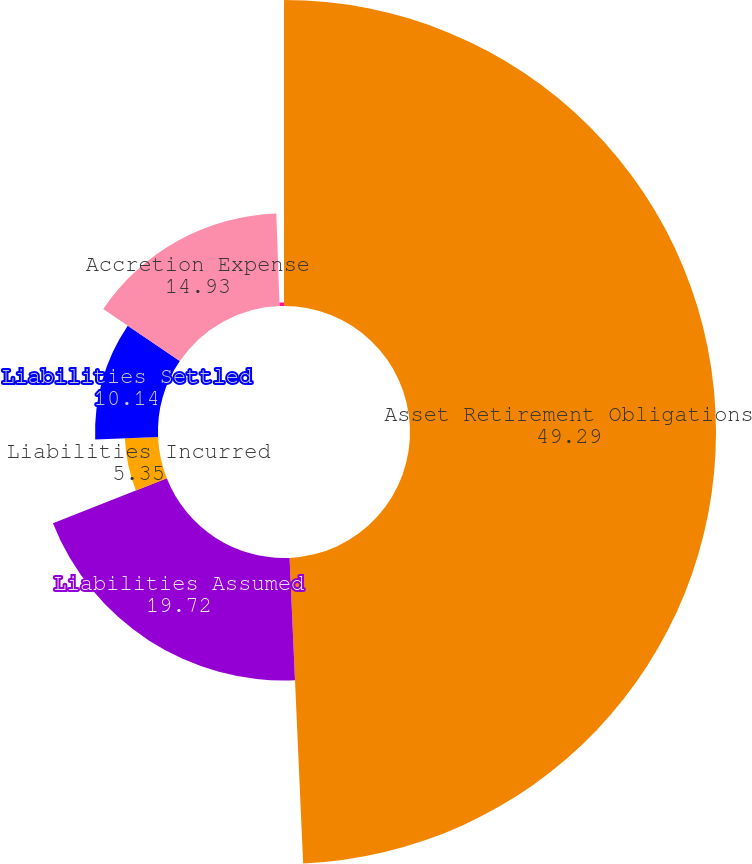Convert chart. <chart><loc_0><loc_0><loc_500><loc_500><pie_chart><fcel>Asset Retirement Obligations<fcel>Liabilities Assumed<fcel>Liabilities Incurred<fcel>Liabilities Settled<fcel>Accretion Expense<fcel>Foreign Currency Translation<nl><fcel>49.29%<fcel>19.72%<fcel>5.35%<fcel>10.14%<fcel>14.93%<fcel>0.56%<nl></chart> 